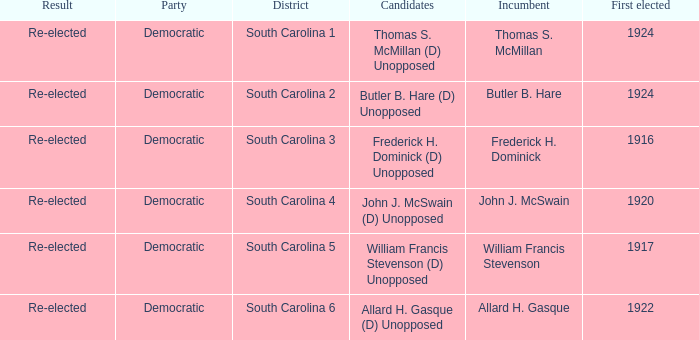Who is the candidate in district south carolina 2? Butler B. Hare (D) Unopposed. 